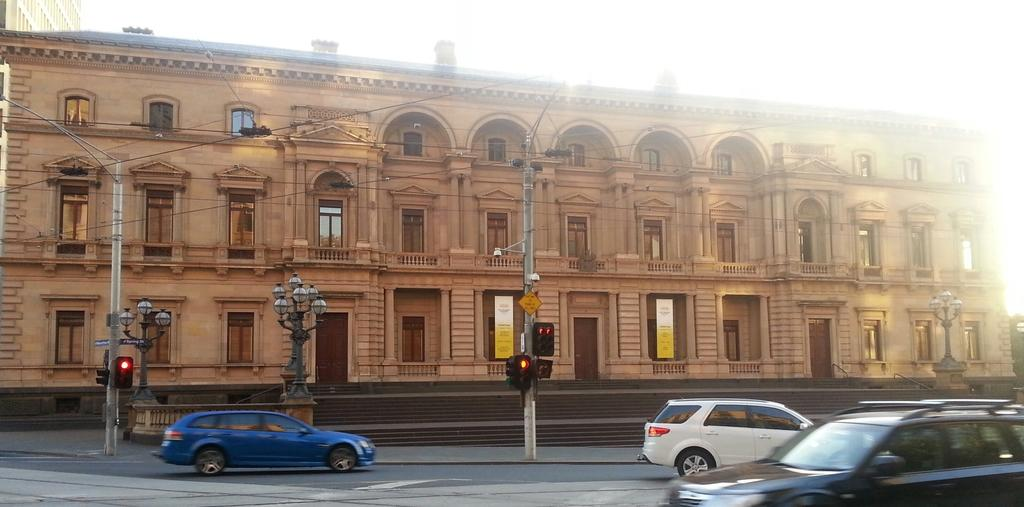What can be seen in the foreground of the image? There are vehicles and poles in the foreground of the image. What is located in the background of the image? There are stairs, a building, and the sky visible in the background of the image. Can you describe the building in the background? The building is in the background of the image, but no specific details about its design or appearance are provided. What type of house is visible in the image? There is no house present in the image. What design elements can be seen on the steps in the image? There are no steps visible in the image, only stairs in the background. 